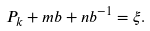<formula> <loc_0><loc_0><loc_500><loc_500>P _ { k } + m b + n b ^ { - 1 } = \xi .</formula> 